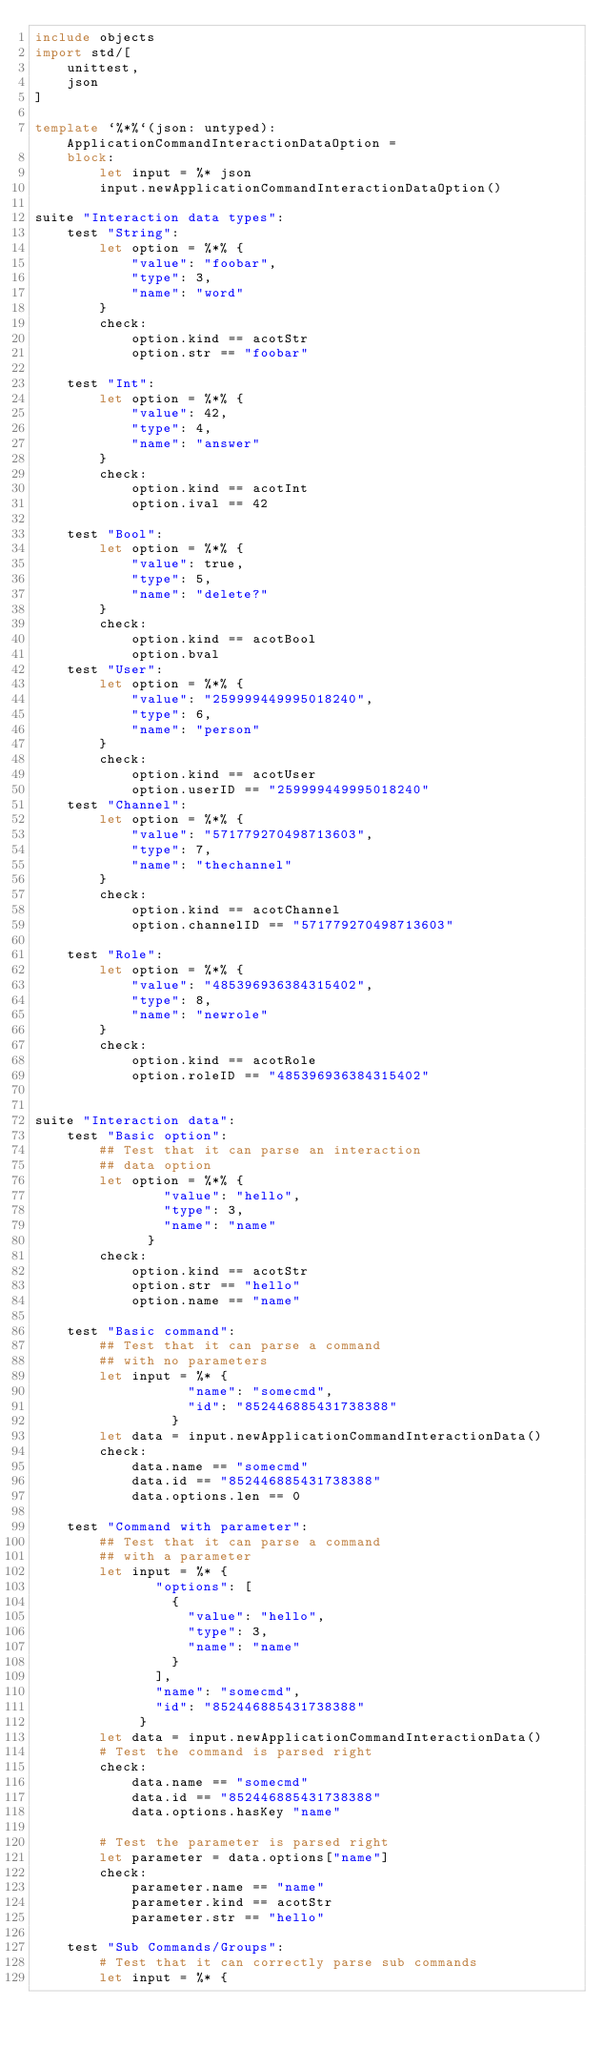Convert code to text. <code><loc_0><loc_0><loc_500><loc_500><_Nim_>include objects
import std/[
    unittest,
    json
]

template `%*%`(json: untyped): ApplicationCommandInteractionDataOption =
    block:
        let input = %* json
        input.newApplicationCommandInteractionDataOption()

suite "Interaction data types":
    test "String":
        let option = %*% {
            "value": "foobar",
            "type": 3,
            "name": "word"
        }
        check:
            option.kind == acotStr
            option.str == "foobar"

    test "Int":
        let option = %*% {
            "value": 42,
            "type": 4,
            "name": "answer"
        }
        check:
            option.kind == acotInt
            option.ival == 42

    test "Bool":
        let option = %*% {
            "value": true,
            "type": 5,
            "name": "delete?"
        }
        check:
            option.kind == acotBool
            option.bval
    test "User":
        let option = %*% {
            "value": "259999449995018240",
            "type": 6,
            "name": "person"
        }
        check:
            option.kind == acotUser
            option.userID == "259999449995018240"
    test "Channel":
        let option = %*% {
            "value": "571779270498713603",
            "type": 7,
            "name": "thechannel"
        }
        check:
            option.kind == acotChannel
            option.channelID == "571779270498713603"

    test "Role":
        let option = %*% {
            "value": "485396936384315402",
            "type": 8,
            "name": "newrole"
        }
        check:
            option.kind == acotRole
            option.roleID == "485396936384315402"


suite "Interaction data":
    test "Basic option":
        ## Test that it can parse an interaction
        ## data option
        let option = %*% {
                "value": "hello",
                "type": 3,
                "name": "name"
              }
        check:
            option.kind == acotStr
            option.str == "hello"
            option.name == "name"

    test "Basic command":
        ## Test that it can parse a command
        ## with no parameters
        let input = %* {
                   "name": "somecmd",
                   "id": "852446885431738388"
                 }
        let data = input.newApplicationCommandInteractionData()
        check:
            data.name == "somecmd"
            data.id == "852446885431738388"
            data.options.len == 0

    test "Command with parameter":
        ## Test that it can parse a command
        ## with a parameter
        let input = %* {
               "options": [
                 {
                   "value": "hello",
                   "type": 3,
                   "name": "name"
                 }
               ],
               "name": "somecmd",
               "id": "852446885431738388"
             }
        let data = input.newApplicationCommandInteractionData()
        # Test the command is parsed right
        check:
            data.name == "somecmd"
            data.id == "852446885431738388"
            data.options.hasKey "name"

        # Test the parameter is parsed right
        let parameter = data.options["name"]
        check:
            parameter.name == "name"
            parameter.kind == acotStr
            parameter.str == "hello"

    test "Sub Commands/Groups":
        # Test that it can correctly parse sub commands
        let input = %* {</code> 